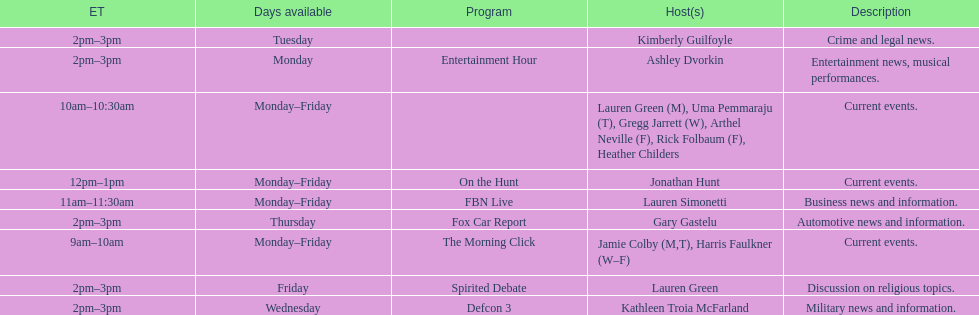Could you parse the entire table as a dict? {'header': ['ET', 'Days available', 'Program', 'Host(s)', 'Description'], 'rows': [['2pm–3pm', 'Tuesday', '', 'Kimberly Guilfoyle', 'Crime and legal news.'], ['2pm–3pm', 'Monday', 'Entertainment Hour', 'Ashley Dvorkin', 'Entertainment news, musical performances.'], ['10am–10:30am', 'Monday–Friday', '', 'Lauren Green (M), Uma Pemmaraju (T), Gregg Jarrett (W), Arthel Neville (F), Rick Folbaum (F), Heather Childers', 'Current events.'], ['12pm–1pm', 'Monday–Friday', 'On the Hunt', 'Jonathan Hunt', 'Current events.'], ['11am–11:30am', 'Monday–Friday', 'FBN Live', 'Lauren Simonetti', 'Business news and information.'], ['2pm–3pm', 'Thursday', 'Fox Car Report', 'Gary Gastelu', 'Automotive news and information.'], ['9am–10am', 'Monday–Friday', 'The Morning Click', 'Jamie Colby (M,T), Harris Faulkner (W–F)', 'Current events.'], ['2pm–3pm', 'Friday', 'Spirited Debate', 'Lauren Green', 'Discussion on religious topics.'], ['2pm–3pm', 'Wednesday', 'Defcon 3', 'Kathleen Troia McFarland', 'Military news and information.']]} How long does on the hunt run? 1 hour. 